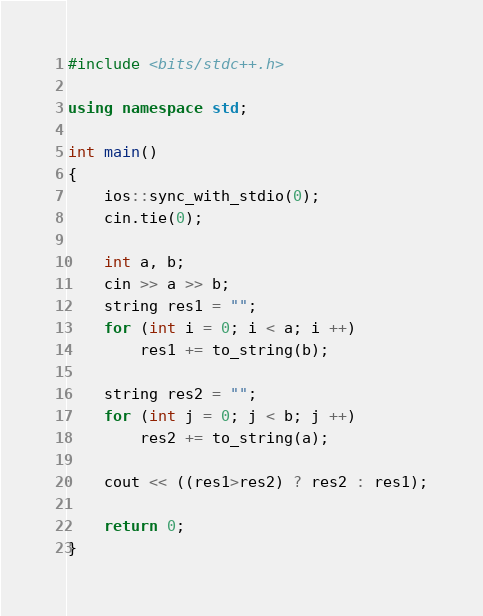<code> <loc_0><loc_0><loc_500><loc_500><_C++_>#include <bits/stdc++.h>

using namespace std;

int main()
{
    ios::sync_with_stdio(0);
    cin.tie(0);

    int a, b;
    cin >> a >> b;
    string res1 = "";
    for (int i = 0; i < a; i ++)
        res1 += to_string(b);
    
    string res2 = "";
    for (int j = 0; j < b; j ++)
        res2 += to_string(a);

    cout << ((res1>res2) ? res2 : res1);
    
    return 0;
}</code> 